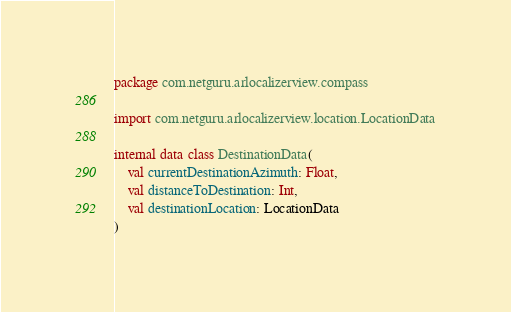Convert code to text. <code><loc_0><loc_0><loc_500><loc_500><_Kotlin_>package com.netguru.arlocalizerview.compass

import com.netguru.arlocalizerview.location.LocationData

internal data class DestinationData(
    val currentDestinationAzimuth: Float,
    val distanceToDestination: Int,
    val destinationLocation: LocationData
)
</code> 